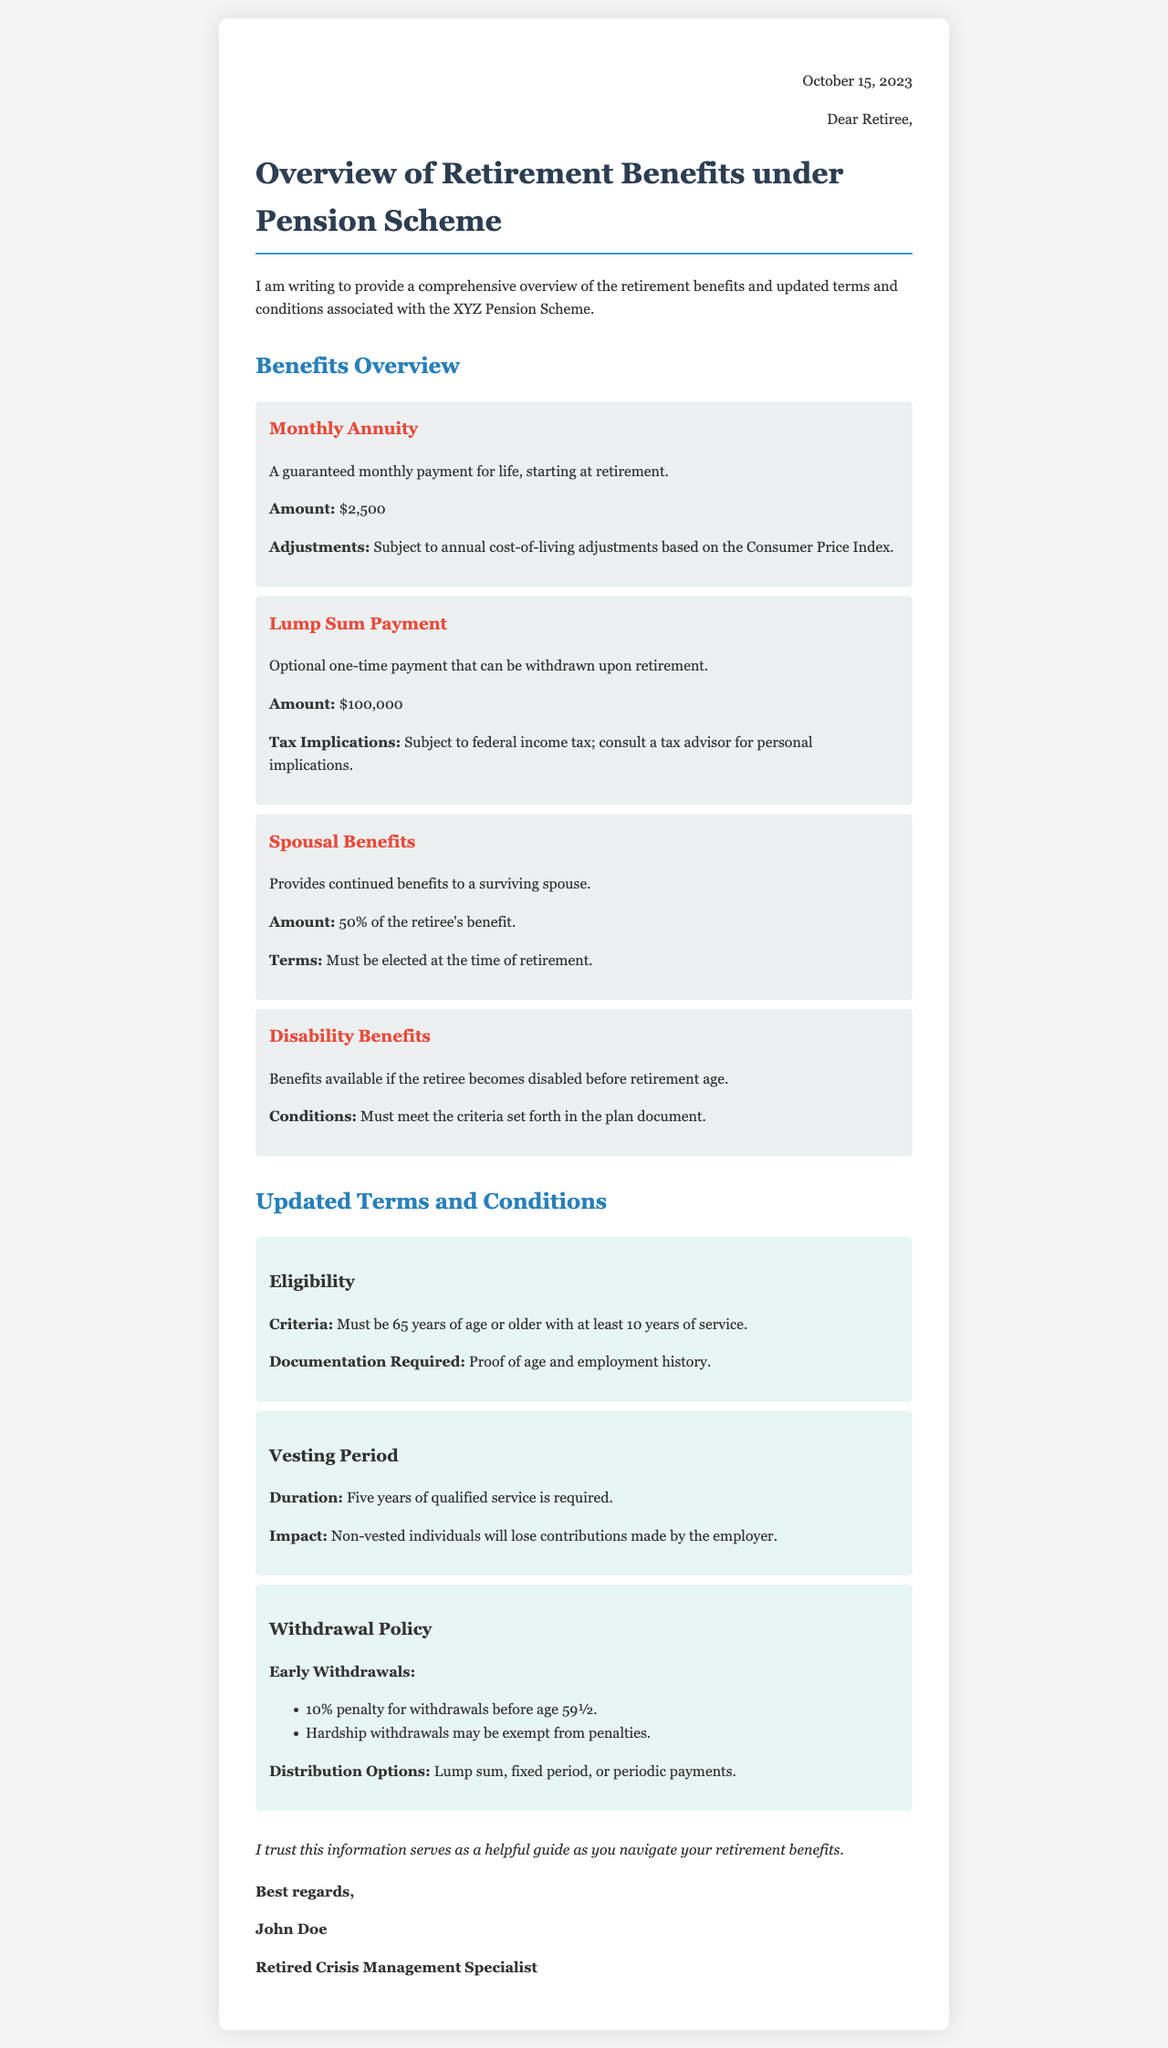What is the monthly annuity amount? The document states that the guaranteed monthly payment for life starting at retirement is $2,500.
Answer: $2,500 What must be elected for spousal benefits? The document specifies that spousal benefits must be elected at the time of retirement.
Answer: At the time of retirement What is the penalty for early withdrawals before age 59½? The document mentions a 10% penalty for withdrawals before age 59½.
Answer: 10% penalty What is the required age for eligibility? It states that one must be 65 years of age or older for eligibility under the pension scheme.
Answer: 65 years How long is the vesting period? The document indicates that a vesting period of five years of qualified service is required.
Answer: Five years What percentage of the retiree's benefit is provided to a surviving spouse? The letter specifies that the spousal benefits amount to 50% of the retiree's benefit.
Answer: 50% What is the lump sum payment amount? The document states that the optional one-time payment that can be withdrawn upon retirement is $100,000.
Answer: $100,000 What is required as documentation for retirement eligibility? The document requires proof of age and employment history as documentation for eligibility.
Answer: Proof of age and employment history What type of benefits are available if the retiree becomes disabled before retirement age? The document notes that disability benefits are available if the retiree becomes disabled before retirement age.
Answer: Disability benefits 